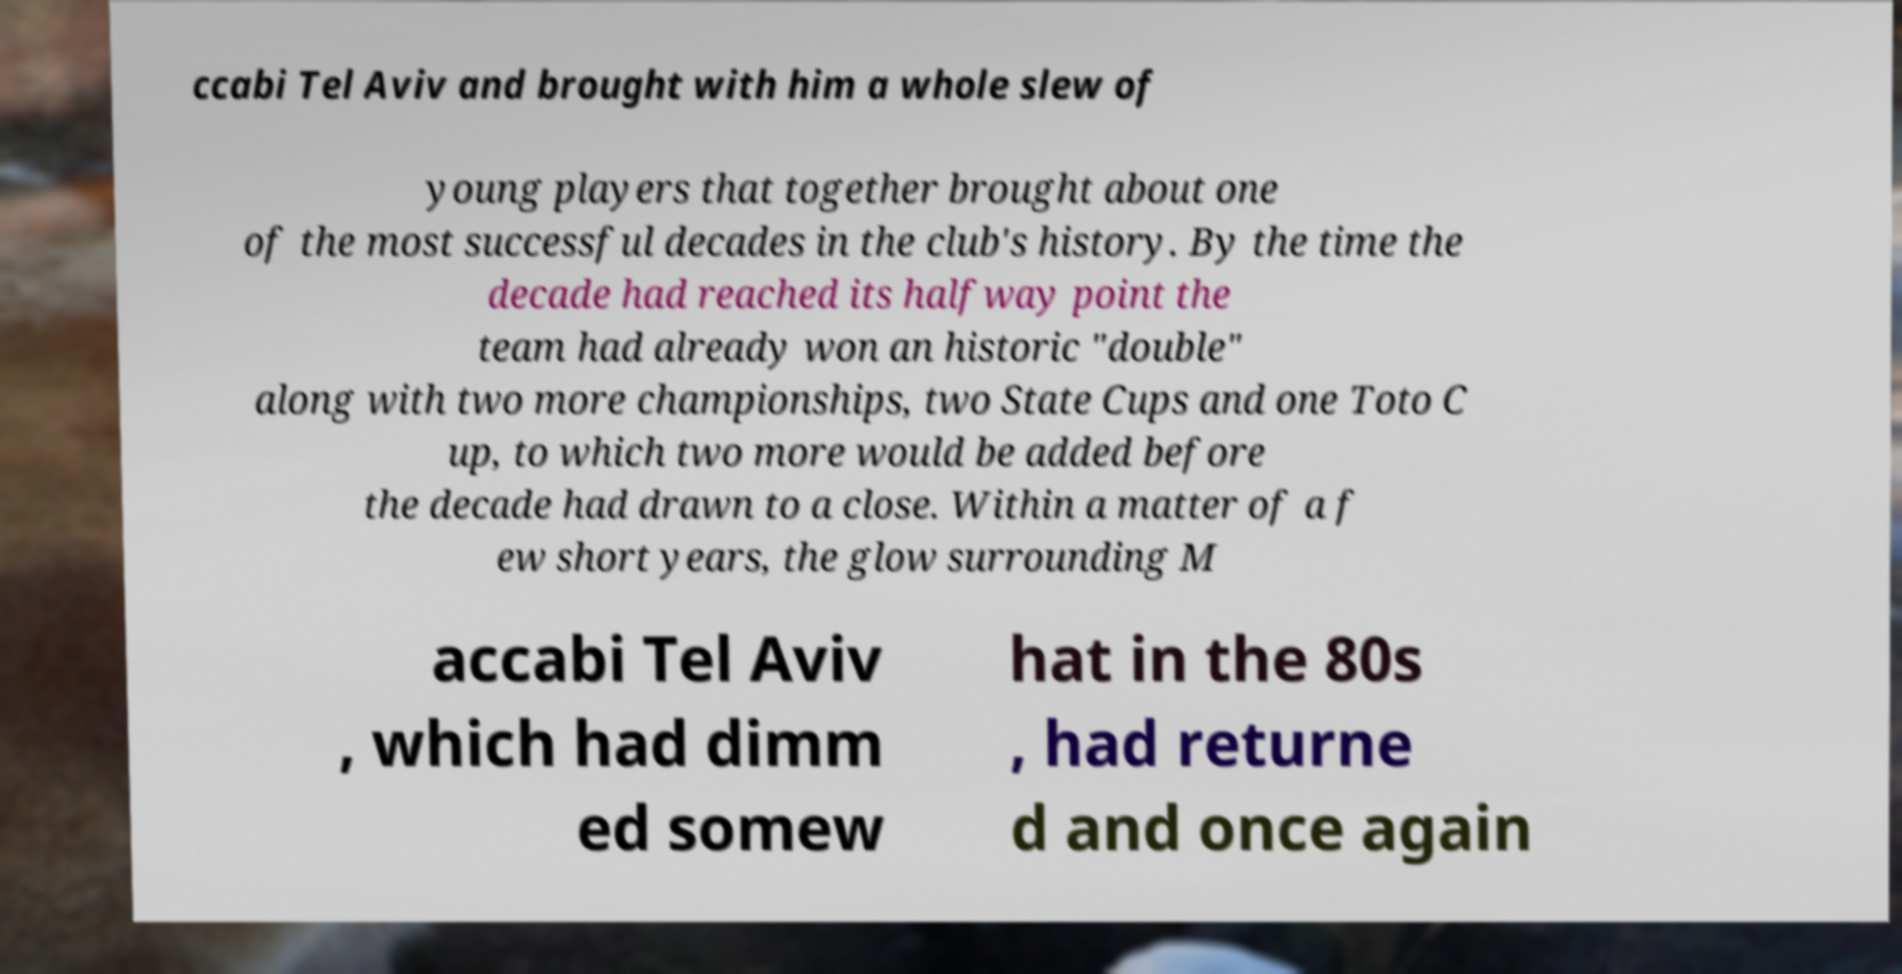Could you assist in decoding the text presented in this image and type it out clearly? ccabi Tel Aviv and brought with him a whole slew of young players that together brought about one of the most successful decades in the club's history. By the time the decade had reached its halfway point the team had already won an historic "double" along with two more championships, two State Cups and one Toto C up, to which two more would be added before the decade had drawn to a close. Within a matter of a f ew short years, the glow surrounding M accabi Tel Aviv , which had dimm ed somew hat in the 80s , had returne d and once again 